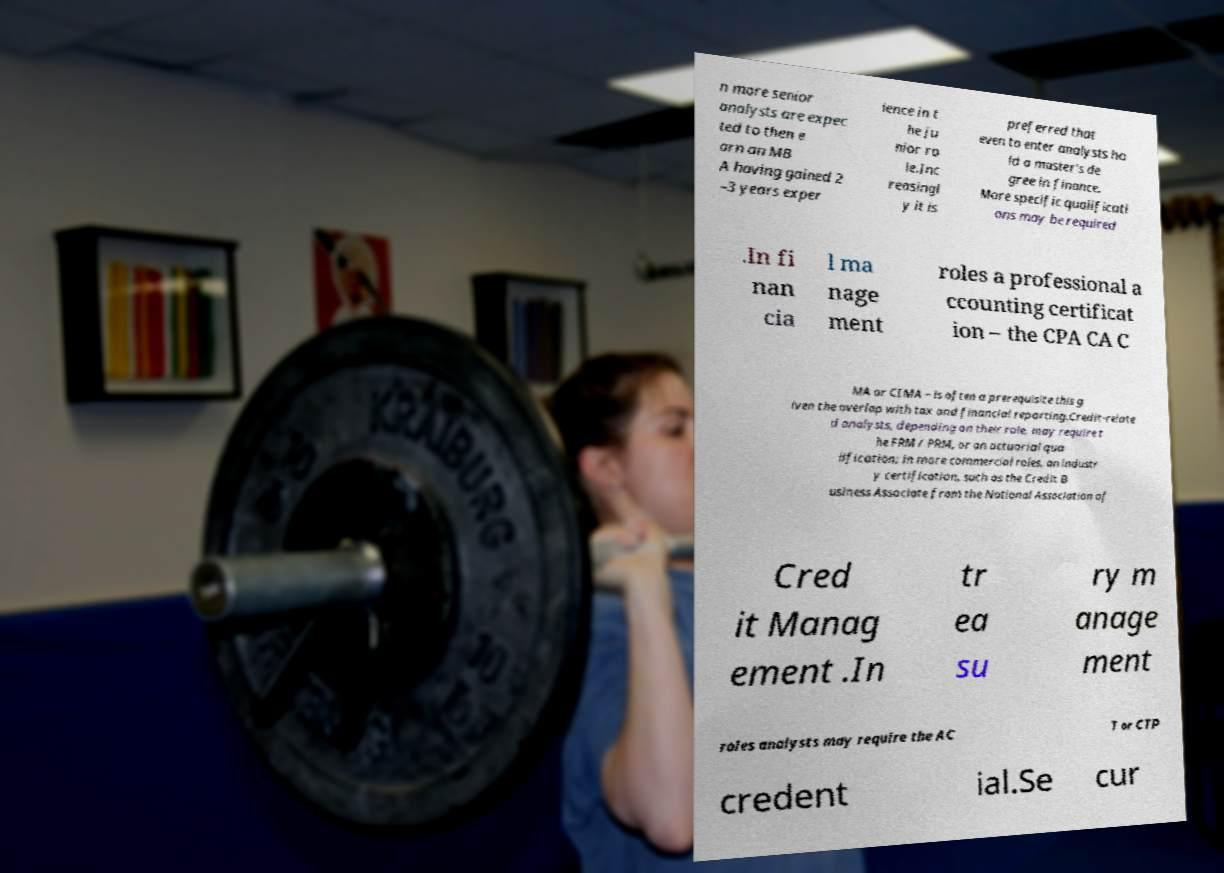I need the written content from this picture converted into text. Can you do that? n more senior analysts are expec ted to then e arn an MB A having gained 2 –3 years exper ience in t he ju nior ro le.Inc reasingl y it is preferred that even to enter analysts ho ld a master's de gree in finance. More specific qualificati ons may be required .In fi nan cia l ma nage ment roles a professional a ccounting certificat ion – the CPA CA C MA or CIMA – is often a prerequisite this g iven the overlap with tax and financial reporting.Credit-relate d analysts, depending on their role, may require t he FRM / PRM, or an actuarial qua lification; in more commercial roles, an industr y certification, such as the Credit B usiness Associate from the National Association of Cred it Manag ement .In tr ea su ry m anage ment roles analysts may require the AC T or CTP credent ial.Se cur 